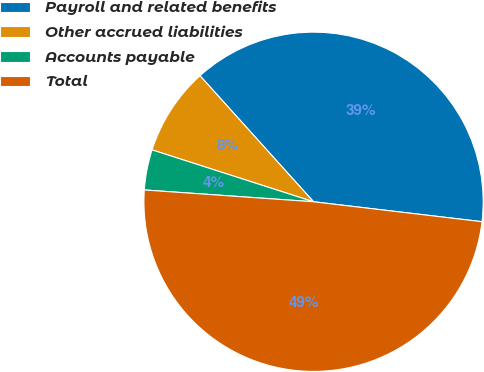Convert chart. <chart><loc_0><loc_0><loc_500><loc_500><pie_chart><fcel>Payroll and related benefits<fcel>Other accrued liabilities<fcel>Accounts payable<fcel>Total<nl><fcel>38.55%<fcel>8.38%<fcel>3.84%<fcel>49.24%<nl></chart> 